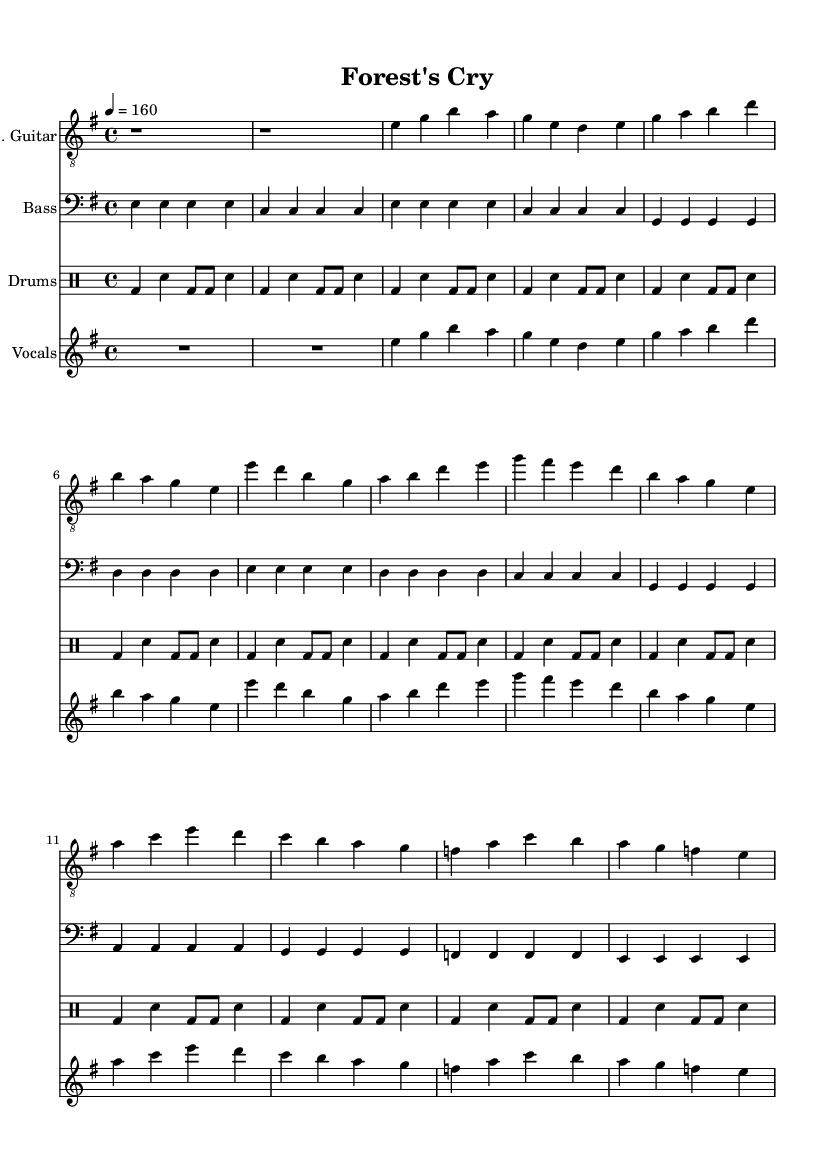what is the key signature of this music? The key signature is noted at the beginning of the music, indicating E minor, which features one sharp (F#).
Answer: E minor what is the time signature of this music? The time signature is indicated at the beginning of the piece, showing a common 4/4 meter, which means there are four beats in each measure.
Answer: 4/4 what is the tempo marking for this piece? The tempo is specified in the score, which is set to 160 beats per minute, indicated by the marking "4 = 160".
Answer: 160 how many sections are in the music? There are distinct sections in the music which can be counted: Intro, Verse 1, Chorus, and Bridge, summing to four sections total.
Answer: 4 how many instruments are included in the score? The score includes four different parts: Electric Guitar, Bass, Drums, and Vocals. Each is clearly labeled in the score layout, showing a total of four instruments.
Answer: 4 what is the main theme of the lyrics conveyed in the score? The lyrics are inferred from the structure, with the phrases and sections implying a theme related to nature and conservation, as reflected in the title "Forest's Cry."
Answer: Nature conservation which instrument plays the intro? The intro is played specifically by the Electric Guitar, as it is the first staff listed in the score.
Answer: Electric Guitar 